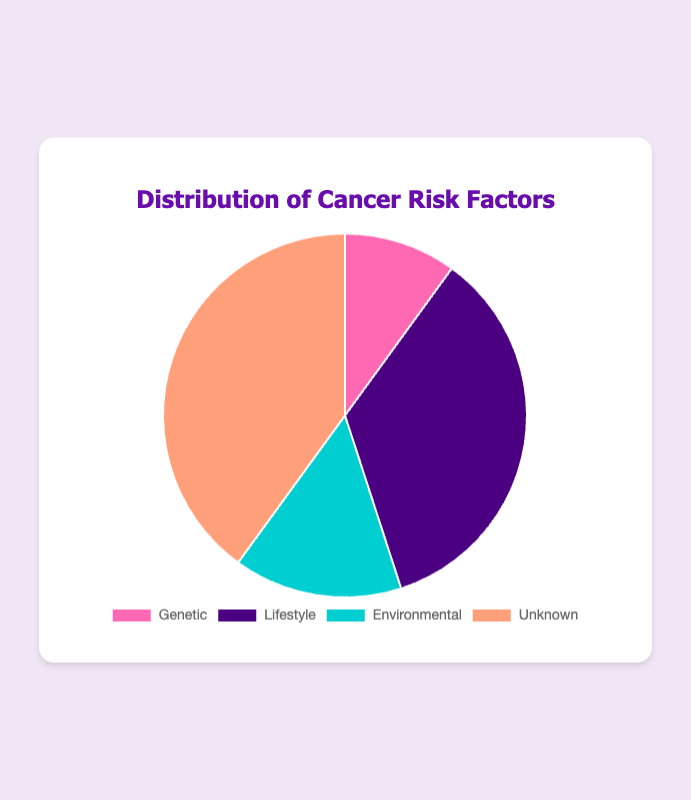What's the most common cancer risk factor as per the pie chart? The pie chart shows the distribution of cancer risk factors. The 'Unknown' category has the highest percentage, which is 40%.
Answer: Unknown Which risk factor has the second highest representation in the pie chart? By observing the chart, after 'Unknown' which is 40%, the 'Lifestyle' category has the next highest percentage with 35%.
Answer: Lifestyle What is the total percentage for genetic and environmental factors combined? The pie chart provides the percentages for 'Genetic' (10%) and 'Environmental' (15%). Adding 10% and 15%, the total is 25%.
Answer: 25% Is the percentage of environmental risk factors greater than that of genetic risk factors? By looking at the chart, the percentage of 'Environmental' risk factors (15%) is greater than that of 'Genetic' risk factors (10%).
Answer: Yes What percentage range does the pie chart use for each risk factor? The pie chart has four categories: 'Genetic' (10%), 'Lifestyle' (35%), 'Environmental' (15%), and 'Unknown' (40%). Each category falls within 0-100%.
Answer: 0-100% Which two risk factors together make up 50% of the total cancer risk factors? From the chart, 'Genetic' is 10% and 'Environmental' is 15%, thus totaling 25%. However, 'Lifestyle' is 35%, which does not fit alone. Combining 'Genetic' (10%) and 'Unknown' (40%) makes 50%.
Answer: Genetic and Unknown How does the percentage of lifestyle risk factors compare to the combined percentage of environmental and genetic factors? The 'Lifestyle' category is 35%. The sum of 'Environmental' (15%) and 'Genetic' (10%) is 25%. Comparing these, 35% is greater than 25%.
Answer: Lifestyle is greater What colors in the pie chart represent the 'Environmental' and 'Unknown' risk factors? By examining the pie chart, 'Environmental' is represented by a shade of blue and 'Unknown' is represented by a shade of salmon.
Answer: Blue for Environmental, Salmon for Unknown If the 'Unknown' category were split equally into a new 'Unknown' and a new category, what would be the percentage for these new categories? The 'Unknown' category is 40%. Dividing 40% by 2, each new category will be 20%.
Answer: 20% each Which risk factor is least represented in the chart, and what is its percentage? The 'Genetic' risk factor is the least represented with a percentage of 10%.
Answer: Genetic, 10% 